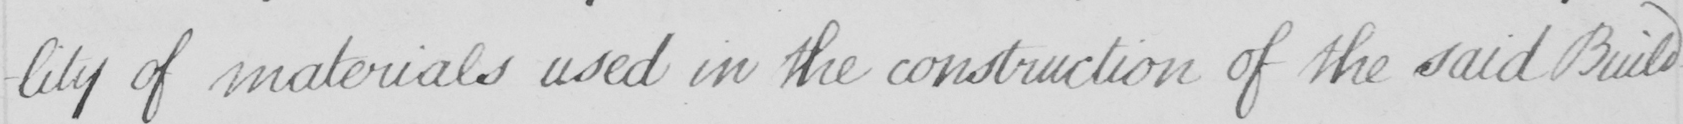What does this handwritten line say? -lity of materials used in the construction of the said Build- 